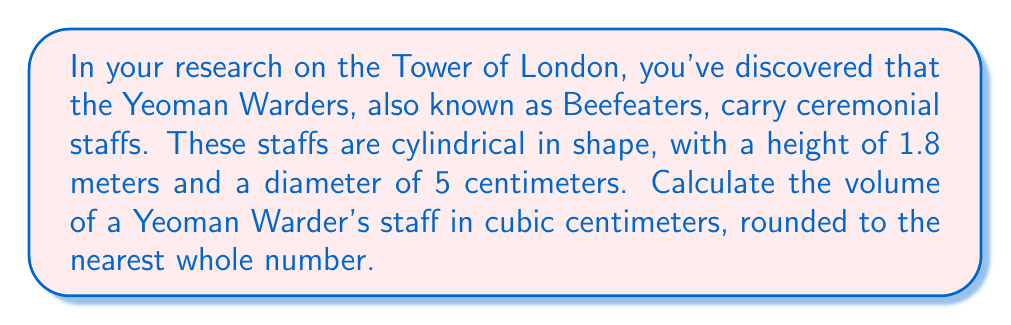Teach me how to tackle this problem. To calculate the volume of the cylindrical staff, we'll use the formula for the volume of a cylinder:

$$V = \pi r^2 h$$

Where:
$V$ = volume
$r$ = radius of the base
$h$ = height of the cylinder

Step 1: Convert all measurements to centimeters.
Height: 1.8 m = 180 cm
Diameter: 5 cm (already in cm)

Step 2: Calculate the radius.
Radius = Diameter ÷ 2
$r = 5 \text{ cm} \div 2 = 2.5 \text{ cm}$

Step 3: Apply the formula.
$$\begin{align*}
V &= \pi r^2 h \\
&= \pi (2.5 \text{ cm})^2 (180 \text{ cm}) \\
&= \pi (6.25 \text{ cm}^2) (180 \text{ cm}) \\
&= 1125\pi \text{ cm}^3 \\
&\approx 3534.29 \text{ cm}^3
\end{align*}$$

Step 4: Round to the nearest whole number.
3534.29 cm³ rounds to 3534 cm³
Answer: 3534 cm³ 